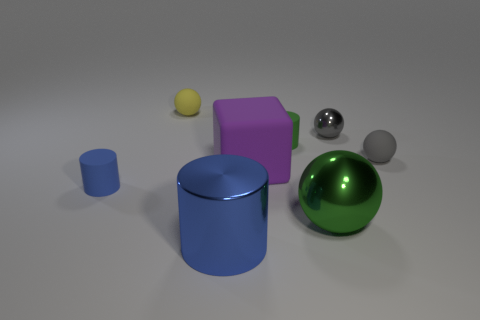What's the texture of the green sphere compared to the silver sphere? The green sphere has a smooth, glossy texture that suggests it might be made out of a material like polished glass or plastic. On the other hand, the silver sphere has a mirror-like finish that reflects the environment, indicative of a metallic texture. Could you speculate on the materials the objects are made from? Based on their appearances, the yellow sphere could be made of a matte plastic, the blue cylinder might be of painted metal due to its blue matte finish, the purple cube resembles a matte finish rubber, the silver sphere seems metallic, and the green sphere likely represents polished glass or a highly glossy plastic. 